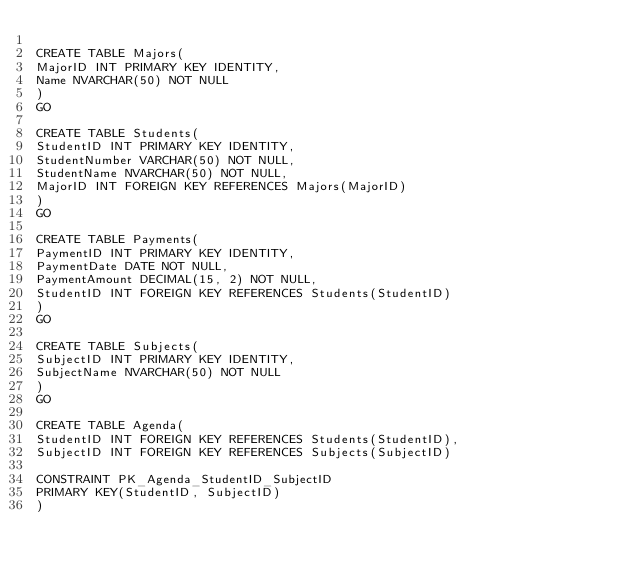Convert code to text. <code><loc_0><loc_0><loc_500><loc_500><_SQL_>
CREATE TABLE Majors(
MajorID INT PRIMARY KEY IDENTITY,
Name NVARCHAR(50) NOT NULL
)
GO

CREATE TABLE Students(
StudentID INT PRIMARY KEY IDENTITY,
StudentNumber VARCHAR(50) NOT NULL,
StudentName NVARCHAR(50) NOT NULL,
MajorID INT FOREIGN KEY REFERENCES Majors(MajorID)
)
GO

CREATE TABLE Payments(
PaymentID INT PRIMARY KEY IDENTITY,
PaymentDate DATE NOT NULL,
PaymentAmount DECIMAL(15, 2) NOT NULL,
StudentID INT FOREIGN KEY REFERENCES Students(StudentID)
)
GO

CREATE TABLE Subjects(
SubjectID INT PRIMARY KEY IDENTITY,
SubjectName NVARCHAR(50) NOT NULL
)
GO

CREATE TABLE Agenda(
StudentID INT FOREIGN KEY REFERENCES Students(StudentID),
SubjectID INT FOREIGN KEY REFERENCES Subjects(SubjectID)

CONSTRAINT PK_Agenda_StudentID_SubjectID
PRIMARY KEY(StudentID, SubjectID)
)</code> 